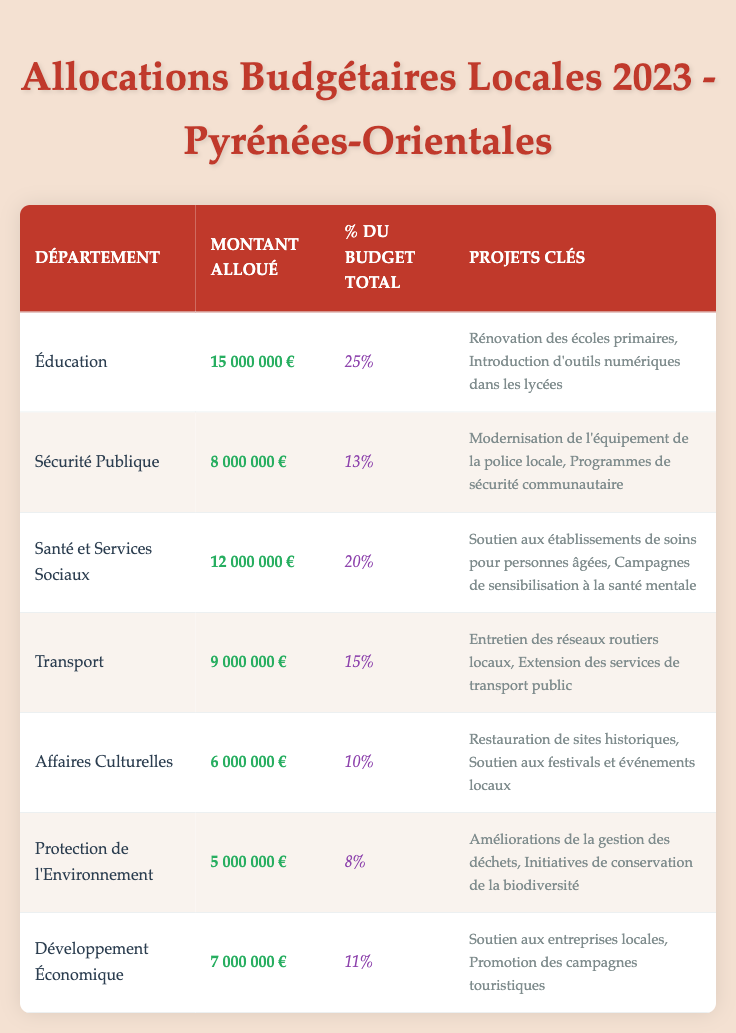What is the total allocation amount for Education and Health and Social Services combined? To find the total allocation amount, we add the amounts for Education (15,000,000 €) and Health and Social Services (12,000,000 €): 15,000,000 € + 12,000,000 € = 27,000,000 €.
Answer: 27,000,000 € Which department received the largest allocation for 2023? By scanning the table, we can see that Education received the largest allocation, which is 15,000,000 €.
Answer: Education What percentage of the total budget is allocated to Environmental Protection? The table indicates that 8% of the total budget is allocated to the Environmental Protection department.
Answer: 8% Is the allocation for Public Safety greater than that for Cultural Affairs? The allocation for Public Safety is 8,000,000 € and that for Cultural Affairs is 6,000,000 €. Since 8,000,000 € > 6,000,000 €, the statement is true.
Answer: Yes What is the average allocation for the departments listed in the table? First, we sum up all allocations: 15,000,000 + 8,000,000 + 12,000,000 + 9,000,000 + 6,000,000 + 5,000,000 + 7,000,000 = 62,000,000 €. There are 7 departments; thus, the average is 62,000,000 € / 7 = 8,857,143 €.
Answer: 8,857,143 € How much more is allocated to Transportation than to Cultural Affairs? The allocation for Transportation is 9,000,000 € and for Cultural Affairs is 6,000,000 €. Subtracting gives us 9,000,000 € - 6,000,000 € = 3,000,000 €.
Answer: 3,000,000 € Which department has the lowest allocation and what is the amount? By reviewing the table, Environmental Protection has the lowest allocation of 5,000,000 €.
Answer: Environmental Protection, 5,000,000 € If we combine the budgets for Cultural Affairs and Economic Development, what is the total? The allocation for Cultural Affairs is 6,000,000 € and that for Economic Development is 7,000,000 €. Adding these gives us 6,000,000 € + 7,000,000 € = 13,000,000 €.
Answer: 13,000,000 € Are there any departments with similar allocation amounts? By comparing the allocations, Health and Social Services (12,000,000 €) and Transportation (9,000,000 €) do not match. Therefore, no two departments have the same allocation according to the table.
Answer: No 